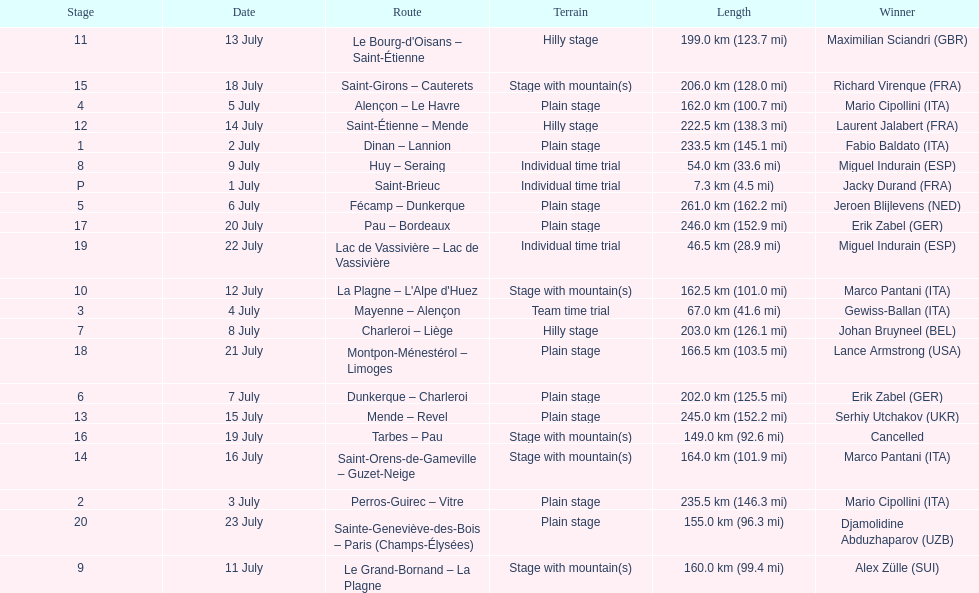How many routes have below 100 km total? 4. 